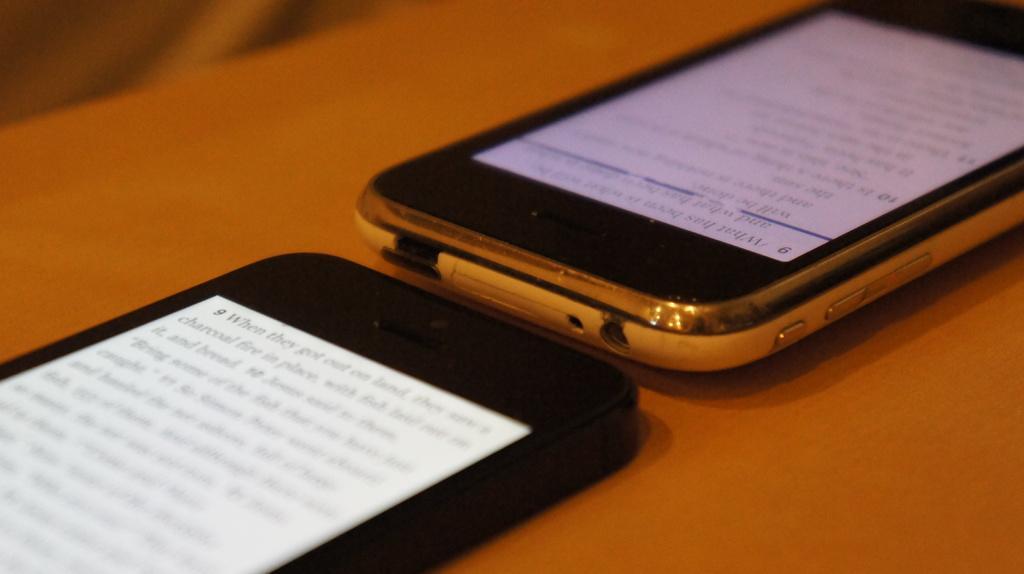In one or two sentences, can you explain what this image depicts? In this image we can see mobiles placed on the table. 